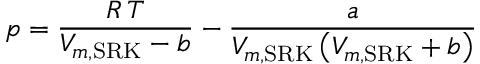<formula> <loc_0><loc_0><loc_500><loc_500>p = { \frac { R \, T } { V _ { m , { S R K } } - b } } - { \frac { a } { V _ { m , { S R K } } \left ( V _ { m , { S R K } } + b \right ) } }</formula> 